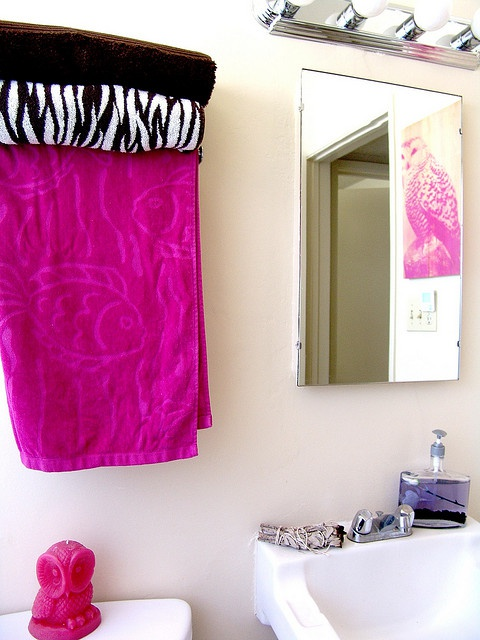Describe the objects in this image and their specific colors. I can see sink in white, lavender, darkgray, gray, and black tones, bird in white, brown, and violet tones, bird in white, lightgray, lightpink, and violet tones, toilet in white, lavender, darkgray, and pink tones, and bottle in white, gray, darkgray, lightgray, and black tones in this image. 